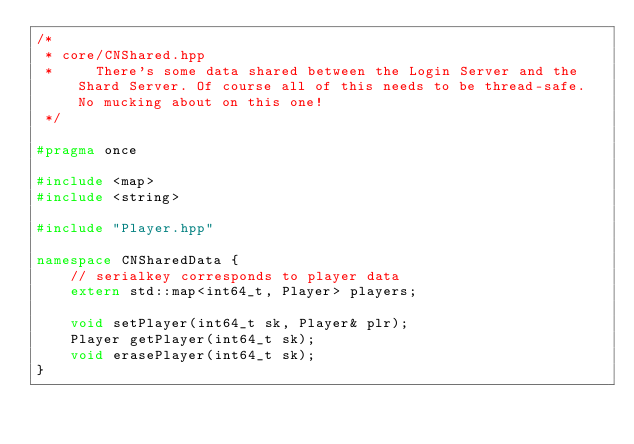Convert code to text. <code><loc_0><loc_0><loc_500><loc_500><_C++_>/*
 * core/CNShared.hpp
 *     There's some data shared between the Login Server and the Shard Server. Of course all of this needs to be thread-safe. No mucking about on this one!
 */

#pragma once

#include <map>
#include <string>

#include "Player.hpp"

namespace CNSharedData {
    // serialkey corresponds to player data
    extern std::map<int64_t, Player> players;

    void setPlayer(int64_t sk, Player& plr);
    Player getPlayer(int64_t sk);
    void erasePlayer(int64_t sk);
}
</code> 